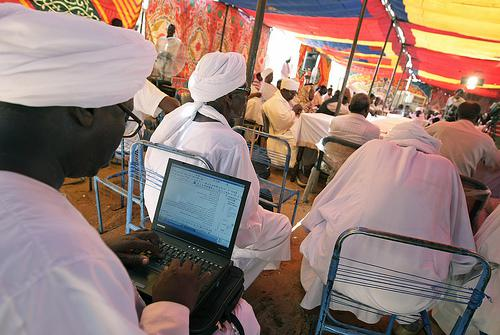Question: what is the man working on?
Choices:
A. Laptop.
B. A desktop.
C. A tablet computer.
D. A book.
Answer with the letter. Answer: A Question: how many laptops are there?
Choices:
A. 2.
B. 3.
C. 1.
D. 4.
Answer with the letter. Answer: C Question: what are the chairs made of?
Choices:
A. Plastic.
B. Rubber.
C. Metal.
D. Wood.
Answer with the letter. Answer: C Question: who is the stage light on?
Choices:
A. The play is going on.
B. The man speaking.
C. The people are dancing.
D. The children are singing.
Answer with the letter. Answer: B Question: what type of building is it?
Choices:
A. Skyscraper.
B. Hut.
C. Tent.
D. School.
Answer with the letter. Answer: C 